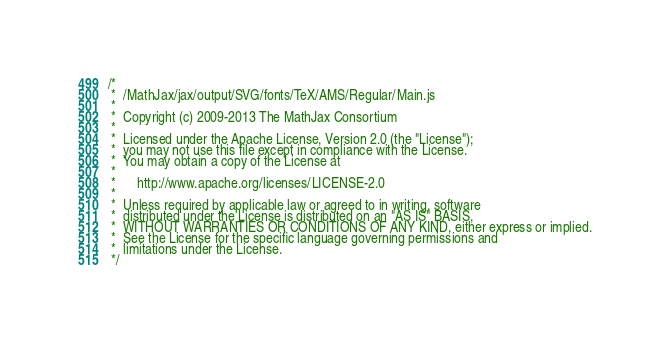Convert code to text. <code><loc_0><loc_0><loc_500><loc_500><_JavaScript_>/*
 *  /MathJax/jax/output/SVG/fonts/TeX/AMS/Regular/Main.js
 *
 *  Copyright (c) 2009-2013 The MathJax Consortium
 *
 *  Licensed under the Apache License, Version 2.0 (the "License");
 *  you may not use this file except in compliance with the License.
 *  You may obtain a copy of the License at
 *
 *      http://www.apache.org/licenses/LICENSE-2.0
 *
 *  Unless required by applicable law or agreed to in writing, software
 *  distributed under the License is distributed on an "AS IS" BASIS,
 *  WITHOUT WARRANTIES OR CONDITIONS OF ANY KIND, either express or implied.
 *  See the License for the specific language governing permissions and
 *  limitations under the License.
 */
</code> 